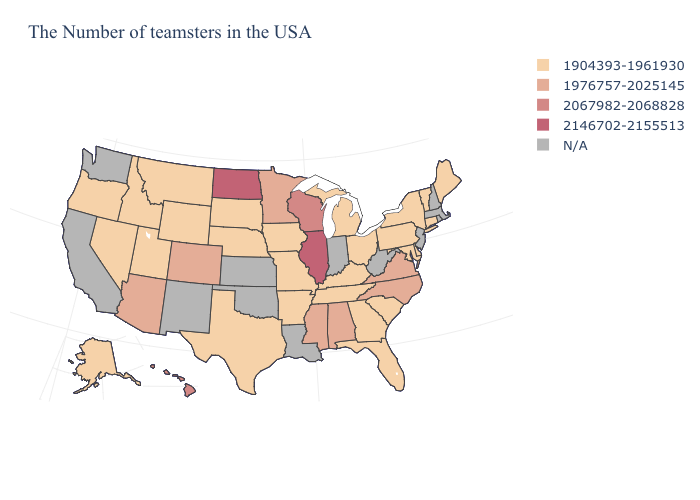What is the value of Wisconsin?
Short answer required. 2067982-2068828. Which states have the lowest value in the USA?
Answer briefly. Maine, Vermont, Connecticut, New York, Delaware, Maryland, Pennsylvania, South Carolina, Ohio, Florida, Georgia, Michigan, Kentucky, Tennessee, Missouri, Arkansas, Iowa, Nebraska, Texas, South Dakota, Wyoming, Utah, Montana, Idaho, Nevada, Oregon, Alaska. Name the states that have a value in the range 1976757-2025145?
Short answer required. Virginia, North Carolina, Alabama, Mississippi, Minnesota, Colorado, Arizona. What is the highest value in the West ?
Keep it brief. 2067982-2068828. What is the value of North Carolina?
Answer briefly. 1976757-2025145. What is the value of West Virginia?
Write a very short answer. N/A. What is the value of Ohio?
Write a very short answer. 1904393-1961930. Does Alaska have the lowest value in the USA?
Give a very brief answer. Yes. What is the highest value in the USA?
Answer briefly. 2146702-2155513. Is the legend a continuous bar?
Be succinct. No. What is the value of New Hampshire?
Give a very brief answer. N/A. What is the value of North Carolina?
Be succinct. 1976757-2025145. What is the highest value in the Northeast ?
Keep it brief. 1904393-1961930. Among the states that border Arkansas , which have the highest value?
Give a very brief answer. Mississippi. 